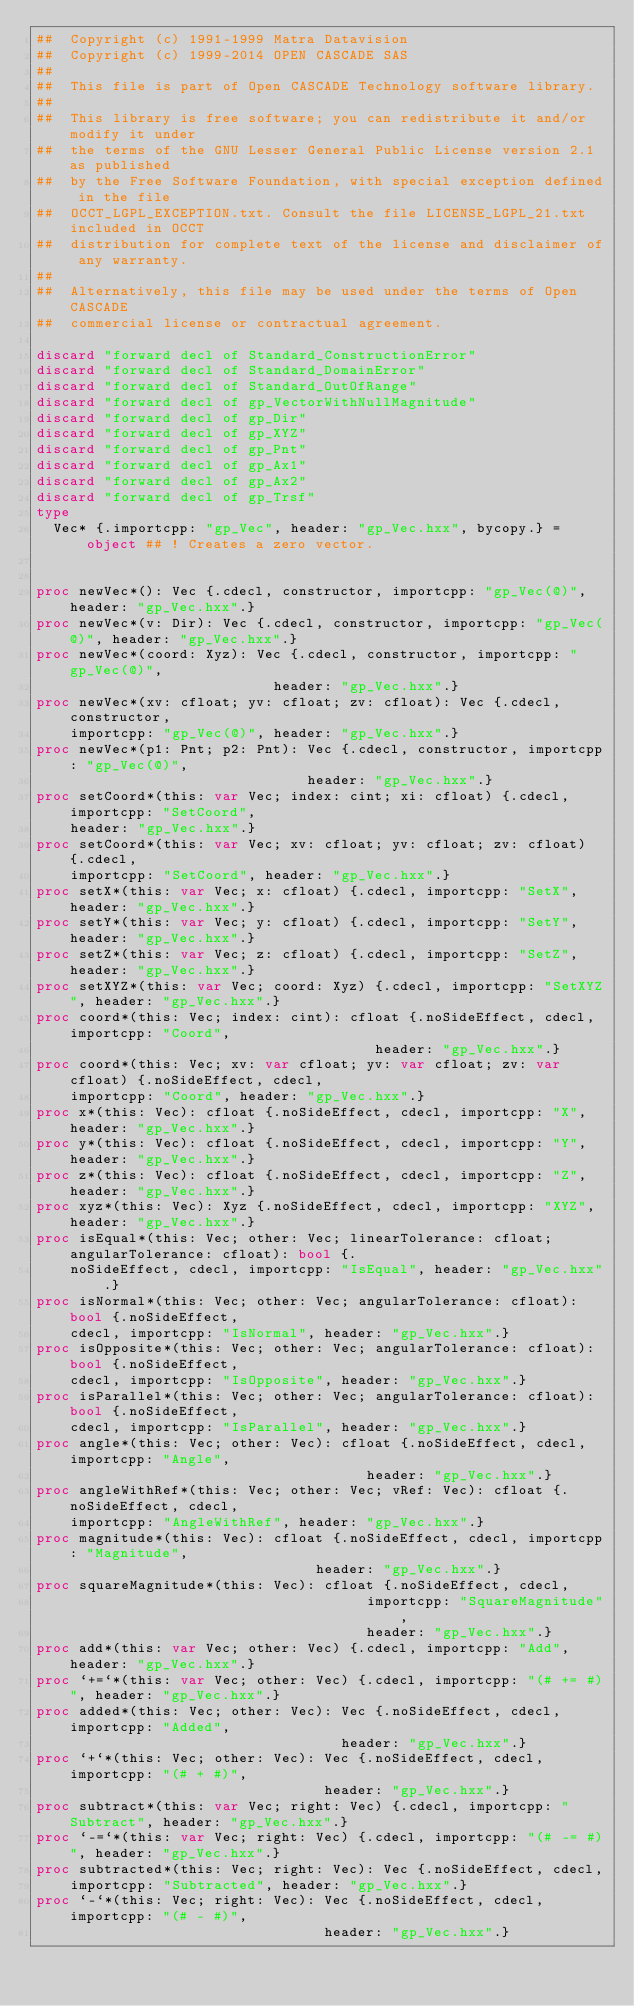<code> <loc_0><loc_0><loc_500><loc_500><_Nim_>##  Copyright (c) 1991-1999 Matra Datavision
##  Copyright (c) 1999-2014 OPEN CASCADE SAS
##
##  This file is part of Open CASCADE Technology software library.
##
##  This library is free software; you can redistribute it and/or modify it under
##  the terms of the GNU Lesser General Public License version 2.1 as published
##  by the Free Software Foundation, with special exception defined in the file
##  OCCT_LGPL_EXCEPTION.txt. Consult the file LICENSE_LGPL_21.txt included in OCCT
##  distribution for complete text of the license and disclaimer of any warranty.
##
##  Alternatively, this file may be used under the terms of Open CASCADE
##  commercial license or contractual agreement.

discard "forward decl of Standard_ConstructionError"
discard "forward decl of Standard_DomainError"
discard "forward decl of Standard_OutOfRange"
discard "forward decl of gp_VectorWithNullMagnitude"
discard "forward decl of gp_Dir"
discard "forward decl of gp_XYZ"
discard "forward decl of gp_Pnt"
discard "forward decl of gp_Ax1"
discard "forward decl of gp_Ax2"
discard "forward decl of gp_Trsf"
type
  Vec* {.importcpp: "gp_Vec", header: "gp_Vec.hxx", bycopy.} = object ## ! Creates a zero vector.


proc newVec*(): Vec {.cdecl, constructor, importcpp: "gp_Vec(@)", header: "gp_Vec.hxx".}
proc newVec*(v: Dir): Vec {.cdecl, constructor, importcpp: "gp_Vec(@)", header: "gp_Vec.hxx".}
proc newVec*(coord: Xyz): Vec {.cdecl, constructor, importcpp: "gp_Vec(@)",
                            header: "gp_Vec.hxx".}
proc newVec*(xv: cfloat; yv: cfloat; zv: cfloat): Vec {.cdecl, constructor,
    importcpp: "gp_Vec(@)", header: "gp_Vec.hxx".}
proc newVec*(p1: Pnt; p2: Pnt): Vec {.cdecl, constructor, importcpp: "gp_Vec(@)",
                                header: "gp_Vec.hxx".}
proc setCoord*(this: var Vec; index: cint; xi: cfloat) {.cdecl, importcpp: "SetCoord",
    header: "gp_Vec.hxx".}
proc setCoord*(this: var Vec; xv: cfloat; yv: cfloat; zv: cfloat) {.cdecl,
    importcpp: "SetCoord", header: "gp_Vec.hxx".}
proc setX*(this: var Vec; x: cfloat) {.cdecl, importcpp: "SetX", header: "gp_Vec.hxx".}
proc setY*(this: var Vec; y: cfloat) {.cdecl, importcpp: "SetY", header: "gp_Vec.hxx".}
proc setZ*(this: var Vec; z: cfloat) {.cdecl, importcpp: "SetZ", header: "gp_Vec.hxx".}
proc setXYZ*(this: var Vec; coord: Xyz) {.cdecl, importcpp: "SetXYZ", header: "gp_Vec.hxx".}
proc coord*(this: Vec; index: cint): cfloat {.noSideEffect, cdecl, importcpp: "Coord",
                                        header: "gp_Vec.hxx".}
proc coord*(this: Vec; xv: var cfloat; yv: var cfloat; zv: var cfloat) {.noSideEffect, cdecl,
    importcpp: "Coord", header: "gp_Vec.hxx".}
proc x*(this: Vec): cfloat {.noSideEffect, cdecl, importcpp: "X", header: "gp_Vec.hxx".}
proc y*(this: Vec): cfloat {.noSideEffect, cdecl, importcpp: "Y", header: "gp_Vec.hxx".}
proc z*(this: Vec): cfloat {.noSideEffect, cdecl, importcpp: "Z", header: "gp_Vec.hxx".}
proc xyz*(this: Vec): Xyz {.noSideEffect, cdecl, importcpp: "XYZ", header: "gp_Vec.hxx".}
proc isEqual*(this: Vec; other: Vec; linearTolerance: cfloat; angularTolerance: cfloat): bool {.
    noSideEffect, cdecl, importcpp: "IsEqual", header: "gp_Vec.hxx".}
proc isNormal*(this: Vec; other: Vec; angularTolerance: cfloat): bool {.noSideEffect,
    cdecl, importcpp: "IsNormal", header: "gp_Vec.hxx".}
proc isOpposite*(this: Vec; other: Vec; angularTolerance: cfloat): bool {.noSideEffect,
    cdecl, importcpp: "IsOpposite", header: "gp_Vec.hxx".}
proc isParallel*(this: Vec; other: Vec; angularTolerance: cfloat): bool {.noSideEffect,
    cdecl, importcpp: "IsParallel", header: "gp_Vec.hxx".}
proc angle*(this: Vec; other: Vec): cfloat {.noSideEffect, cdecl, importcpp: "Angle",
                                       header: "gp_Vec.hxx".}
proc angleWithRef*(this: Vec; other: Vec; vRef: Vec): cfloat {.noSideEffect, cdecl,
    importcpp: "AngleWithRef", header: "gp_Vec.hxx".}
proc magnitude*(this: Vec): cfloat {.noSideEffect, cdecl, importcpp: "Magnitude",
                                 header: "gp_Vec.hxx".}
proc squareMagnitude*(this: Vec): cfloat {.noSideEffect, cdecl,
                                       importcpp: "SquareMagnitude",
                                       header: "gp_Vec.hxx".}
proc add*(this: var Vec; other: Vec) {.cdecl, importcpp: "Add", header: "gp_Vec.hxx".}
proc `+=`*(this: var Vec; other: Vec) {.cdecl, importcpp: "(# += #)", header: "gp_Vec.hxx".}
proc added*(this: Vec; other: Vec): Vec {.noSideEffect, cdecl, importcpp: "Added",
                                    header: "gp_Vec.hxx".}
proc `+`*(this: Vec; other: Vec): Vec {.noSideEffect, cdecl, importcpp: "(# + #)",
                                  header: "gp_Vec.hxx".}
proc subtract*(this: var Vec; right: Vec) {.cdecl, importcpp: "Subtract", header: "gp_Vec.hxx".}
proc `-=`*(this: var Vec; right: Vec) {.cdecl, importcpp: "(# -= #)", header: "gp_Vec.hxx".}
proc subtracted*(this: Vec; right: Vec): Vec {.noSideEffect, cdecl,
    importcpp: "Subtracted", header: "gp_Vec.hxx".}
proc `-`*(this: Vec; right: Vec): Vec {.noSideEffect, cdecl, importcpp: "(# - #)",
                                  header: "gp_Vec.hxx".}</code> 